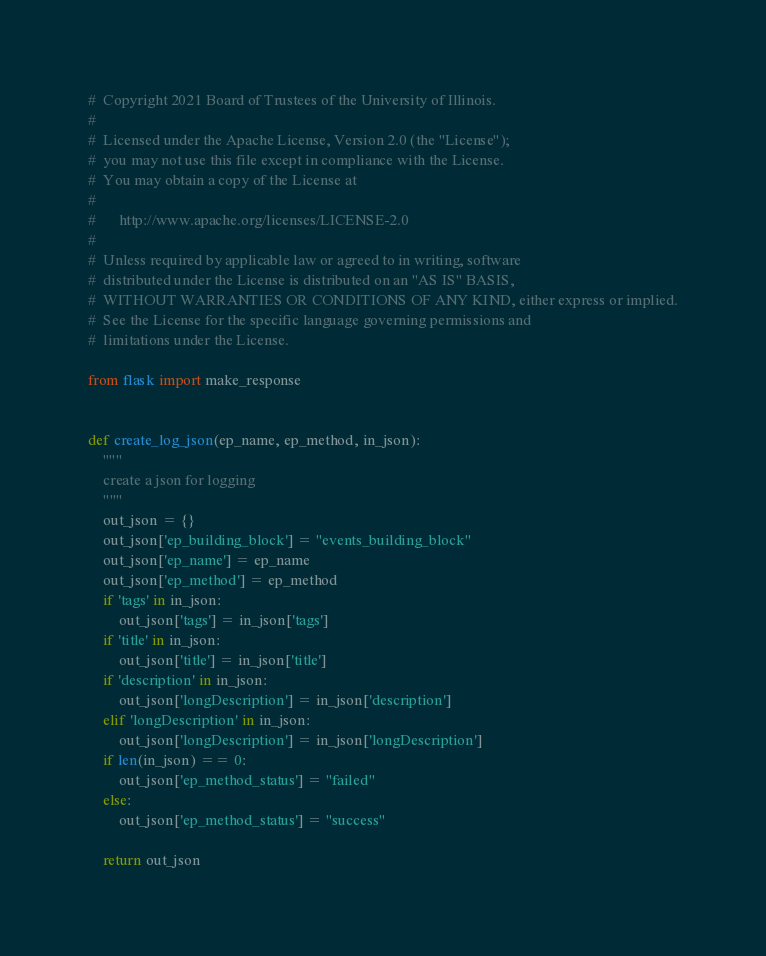<code> <loc_0><loc_0><loc_500><loc_500><_Python_>#  Copyright 2021 Board of Trustees of the University of Illinois.
# 
#  Licensed under the Apache License, Version 2.0 (the "License");
#  you may not use this file except in compliance with the License.
#  You may obtain a copy of the License at
# 
#      http://www.apache.org/licenses/LICENSE-2.0
# 
#  Unless required by applicable law or agreed to in writing, software
#  distributed under the License is distributed on an "AS IS" BASIS,
#  WITHOUT WARRANTIES OR CONDITIONS OF ANY KIND, either express or implied.
#  See the License for the specific language governing permissions and
#  limitations under the License.

from flask import make_response


def create_log_json(ep_name, ep_method, in_json):
    """
    create a json for logging
    """
    out_json = {}
    out_json['ep_building_block'] = "events_building_block"
    out_json['ep_name'] = ep_name
    out_json['ep_method'] = ep_method
    if 'tags' in in_json:
        out_json['tags'] = in_json['tags']
    if 'title' in in_json:
        out_json['title'] = in_json['title']
    if 'description' in in_json:
        out_json['longDescription'] = in_json['description']
    elif 'longDescription' in in_json:
        out_json['longDescription'] = in_json['longDescription']
    if len(in_json) == 0:
        out_json['ep_method_status'] = "failed"
    else:
        out_json['ep_method_status'] = "success"

    return out_json
</code> 